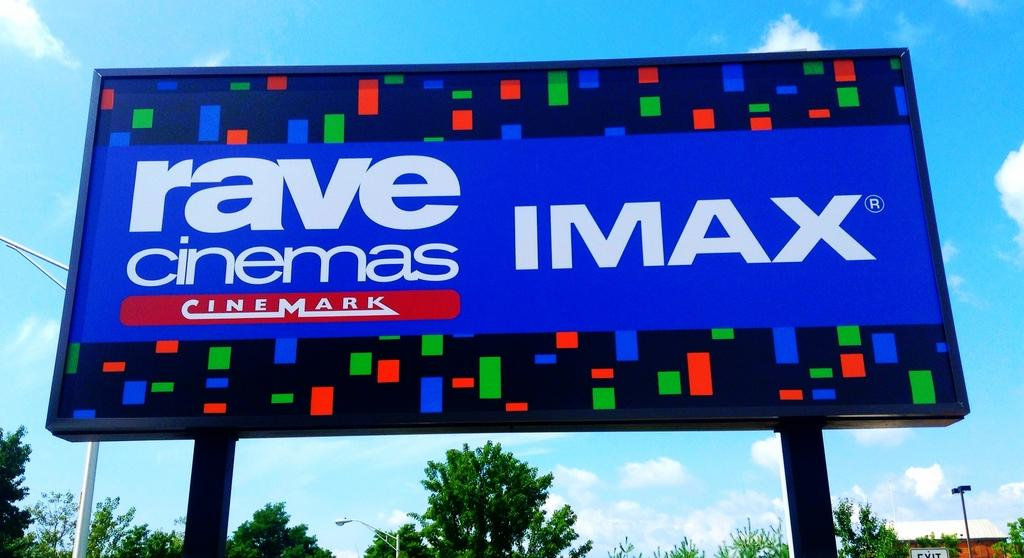<image>
Summarize the visual content of the image. the word IMAX is on the front of a blue sign 